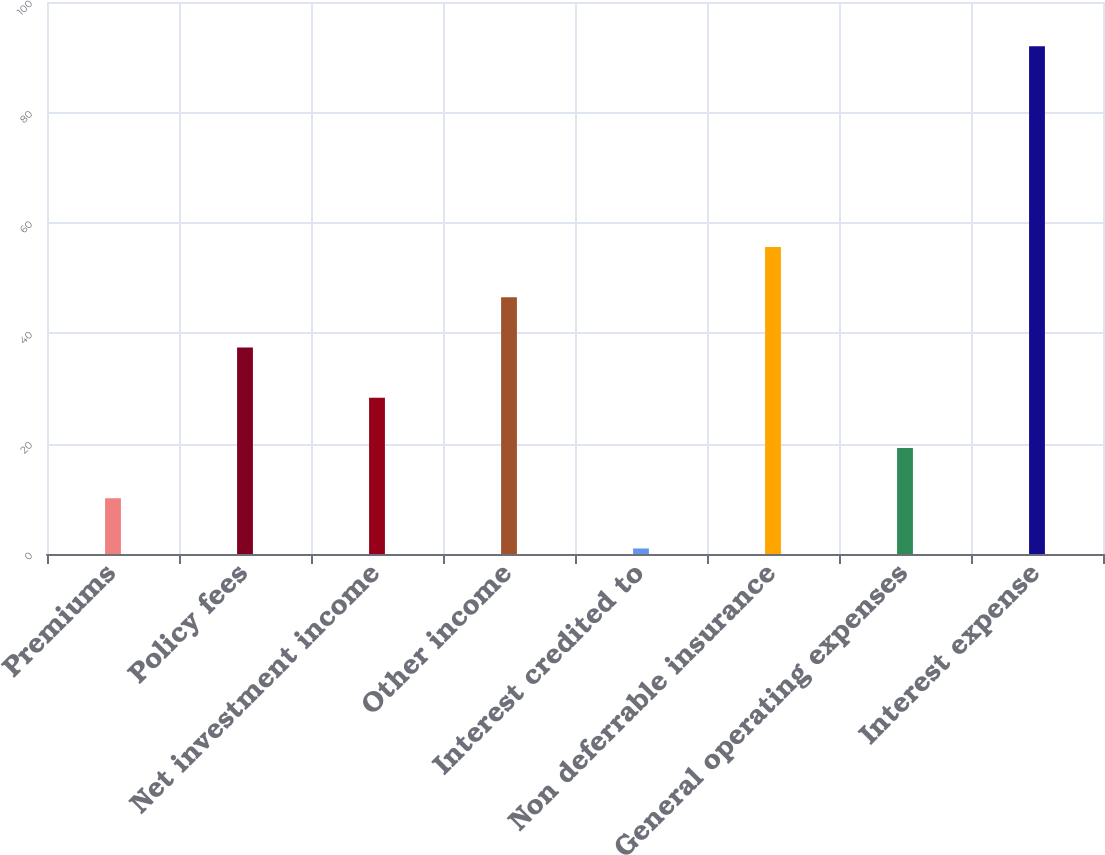<chart> <loc_0><loc_0><loc_500><loc_500><bar_chart><fcel>Premiums<fcel>Policy fees<fcel>Net investment income<fcel>Other income<fcel>Interest credited to<fcel>Non deferrable insurance<fcel>General operating expenses<fcel>Interest expense<nl><fcel>10.1<fcel>37.4<fcel>28.3<fcel>46.5<fcel>1<fcel>55.6<fcel>19.2<fcel>92<nl></chart> 